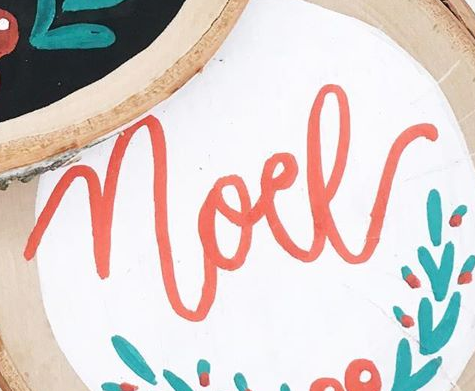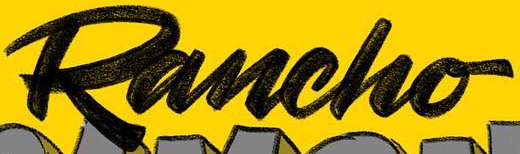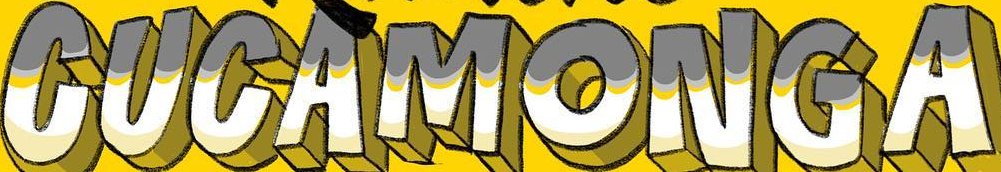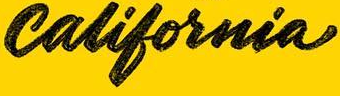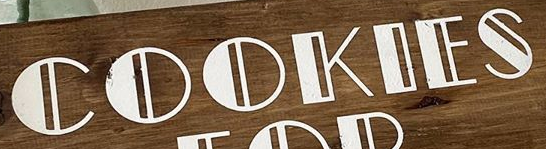What text is displayed in these images sequentially, separated by a semicolon? noel; Rancho; CUCAMONGA; california; COOKIES 